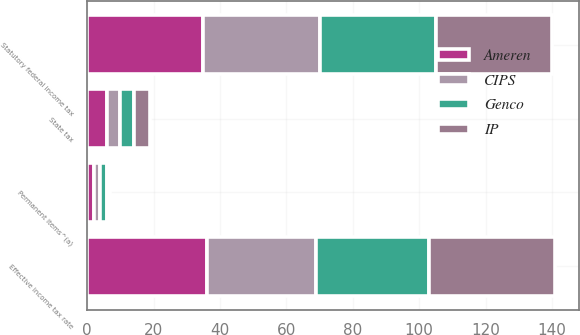<chart> <loc_0><loc_0><loc_500><loc_500><stacked_bar_chart><ecel><fcel>Statutory federal income tax<fcel>Permanent items^(a)<fcel>State tax<fcel>Effective income tax rate<nl><fcel>Genco<fcel>35<fcel>2<fcel>4<fcel>34<nl><fcel>CIPS<fcel>35<fcel>2<fcel>4<fcel>33<nl><fcel>Ameren<fcel>35<fcel>2<fcel>6<fcel>36<nl><fcel>IP<fcel>35<fcel>1<fcel>5<fcel>38<nl></chart> 